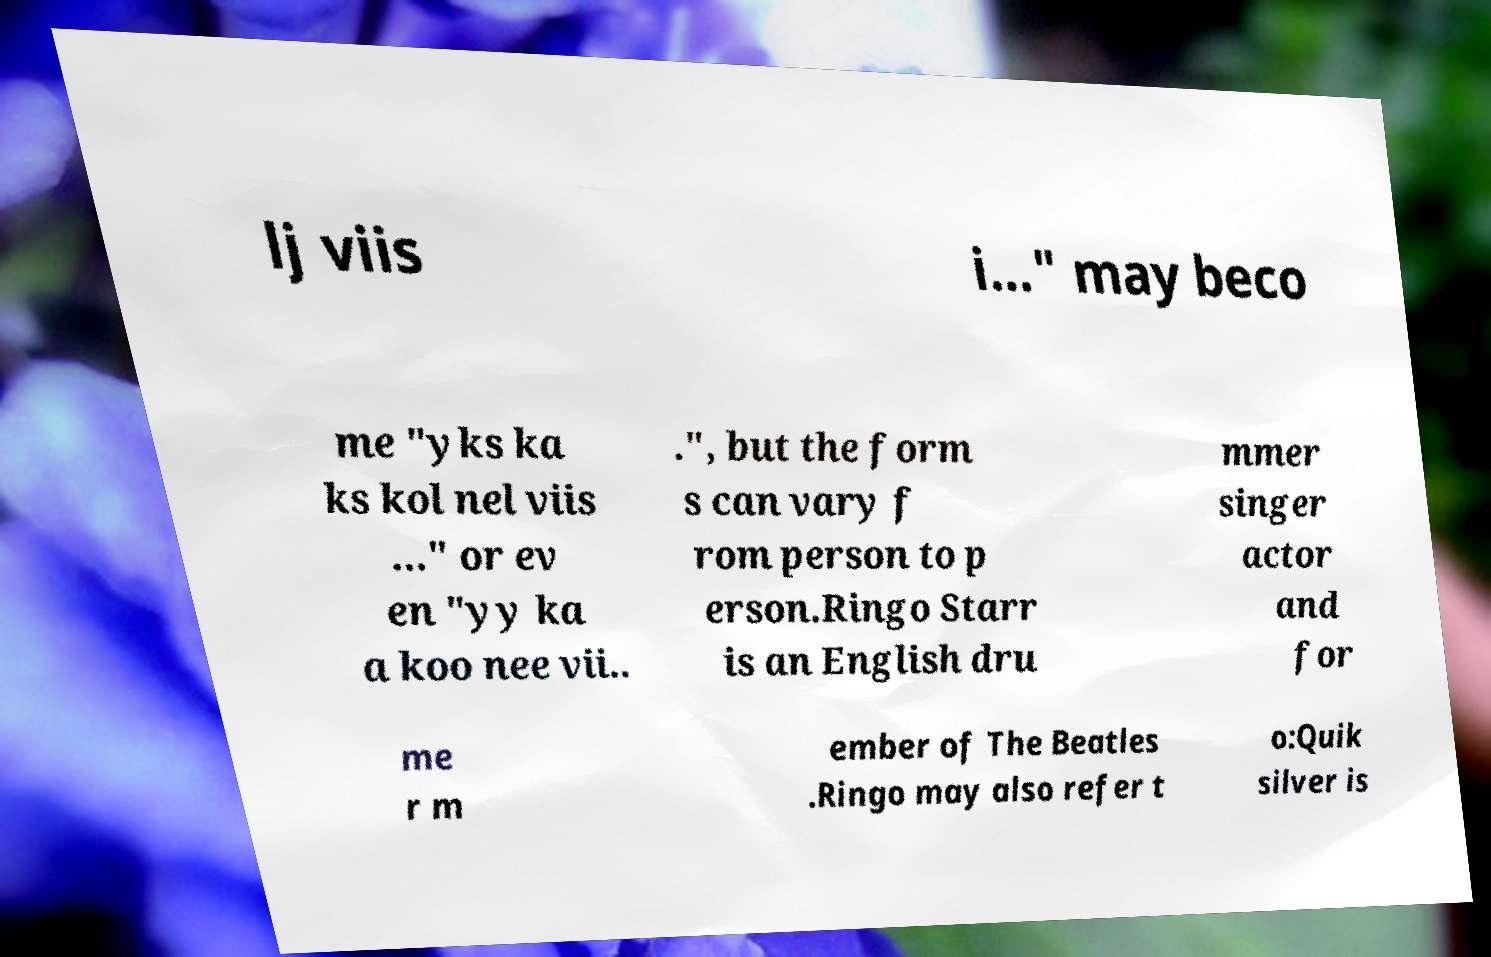There's text embedded in this image that I need extracted. Can you transcribe it verbatim? lj viis i..." may beco me "yks ka ks kol nel viis ..." or ev en "yy ka a koo nee vii.. .", but the form s can vary f rom person to p erson.Ringo Starr is an English dru mmer singer actor and for me r m ember of The Beatles .Ringo may also refer t o:Quik silver is 